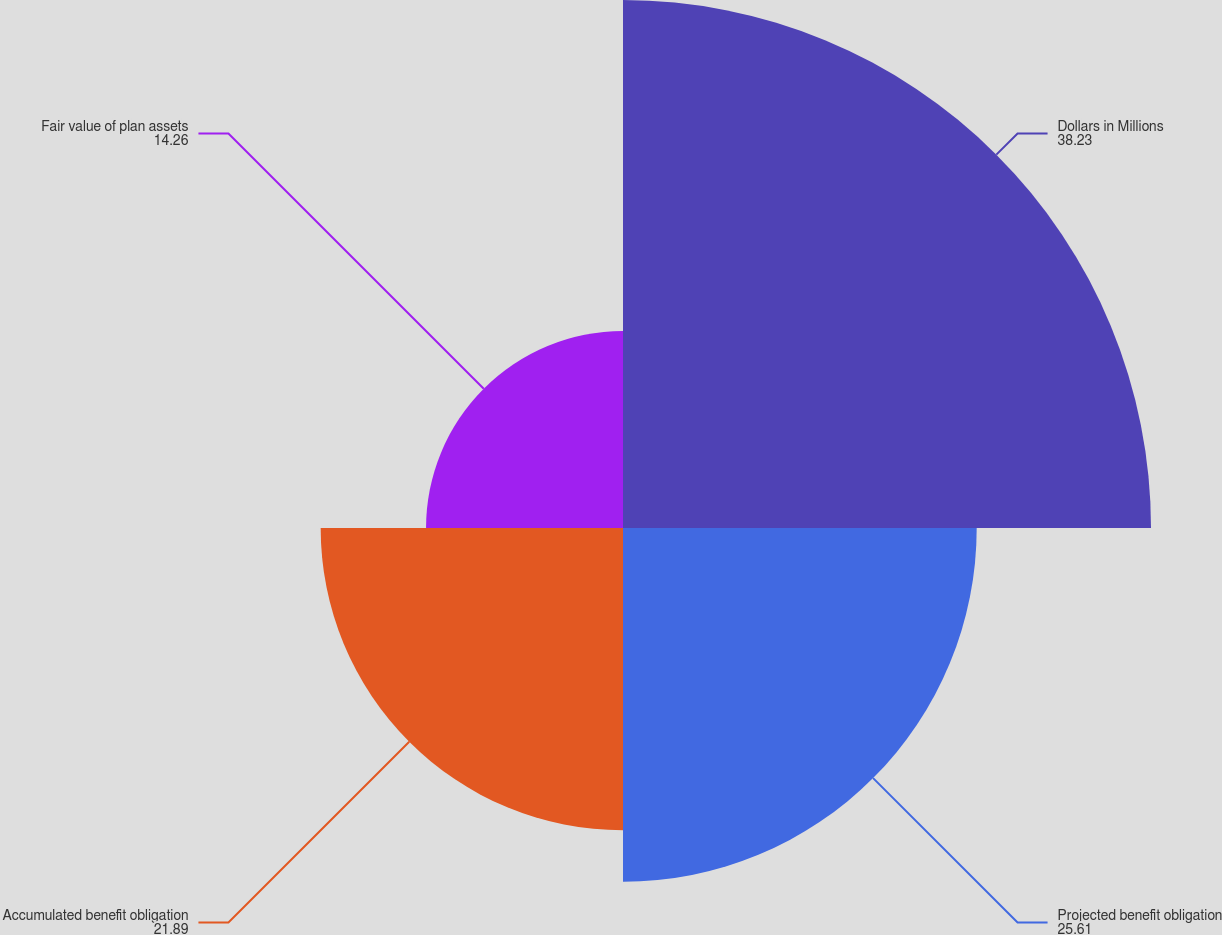<chart> <loc_0><loc_0><loc_500><loc_500><pie_chart><fcel>Dollars in Millions<fcel>Projected benefit obligation<fcel>Accumulated benefit obligation<fcel>Fair value of plan assets<nl><fcel>38.23%<fcel>25.61%<fcel>21.89%<fcel>14.26%<nl></chart> 